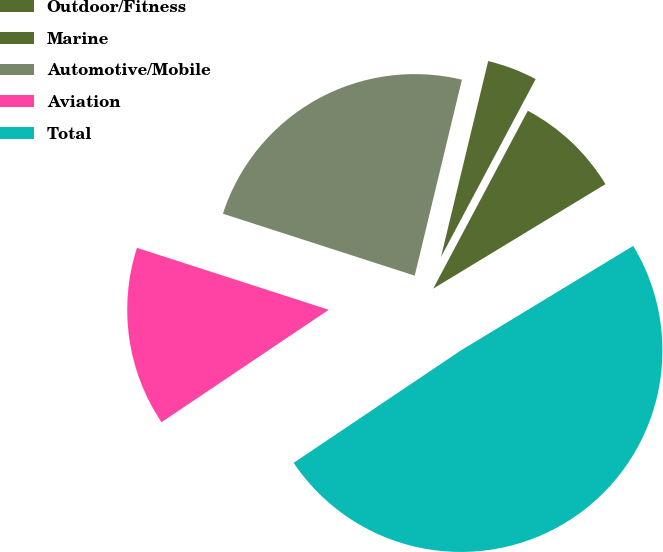Convert chart. <chart><loc_0><loc_0><loc_500><loc_500><pie_chart><fcel>Outdoor/Fitness<fcel>Marine<fcel>Automotive/Mobile<fcel>Aviation<fcel>Total<nl><fcel>8.54%<fcel>4.02%<fcel>23.79%<fcel>14.39%<fcel>49.26%<nl></chart> 